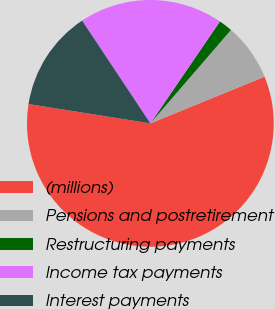Convert chart. <chart><loc_0><loc_0><loc_500><loc_500><pie_chart><fcel>(millions)<fcel>Pensions and postretirement<fcel>Restructuring payments<fcel>Income tax payments<fcel>Interest payments<nl><fcel>58.68%<fcel>7.49%<fcel>1.8%<fcel>18.86%<fcel>13.17%<nl></chart> 